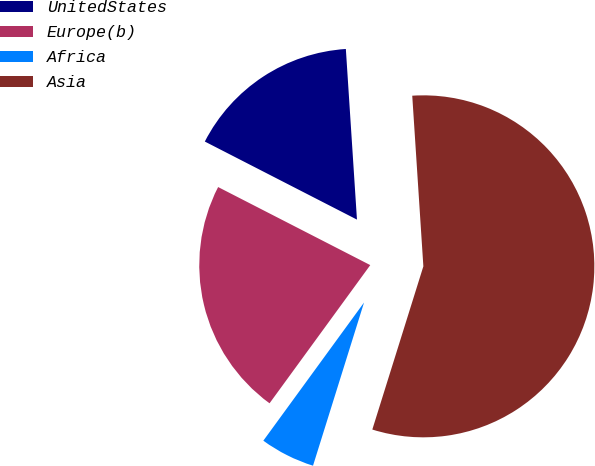Convert chart to OTSL. <chart><loc_0><loc_0><loc_500><loc_500><pie_chart><fcel>UnitedStates<fcel>Europe(b)<fcel>Africa<fcel>Asia<nl><fcel>16.42%<fcel>22.52%<fcel>5.2%<fcel>55.86%<nl></chart> 